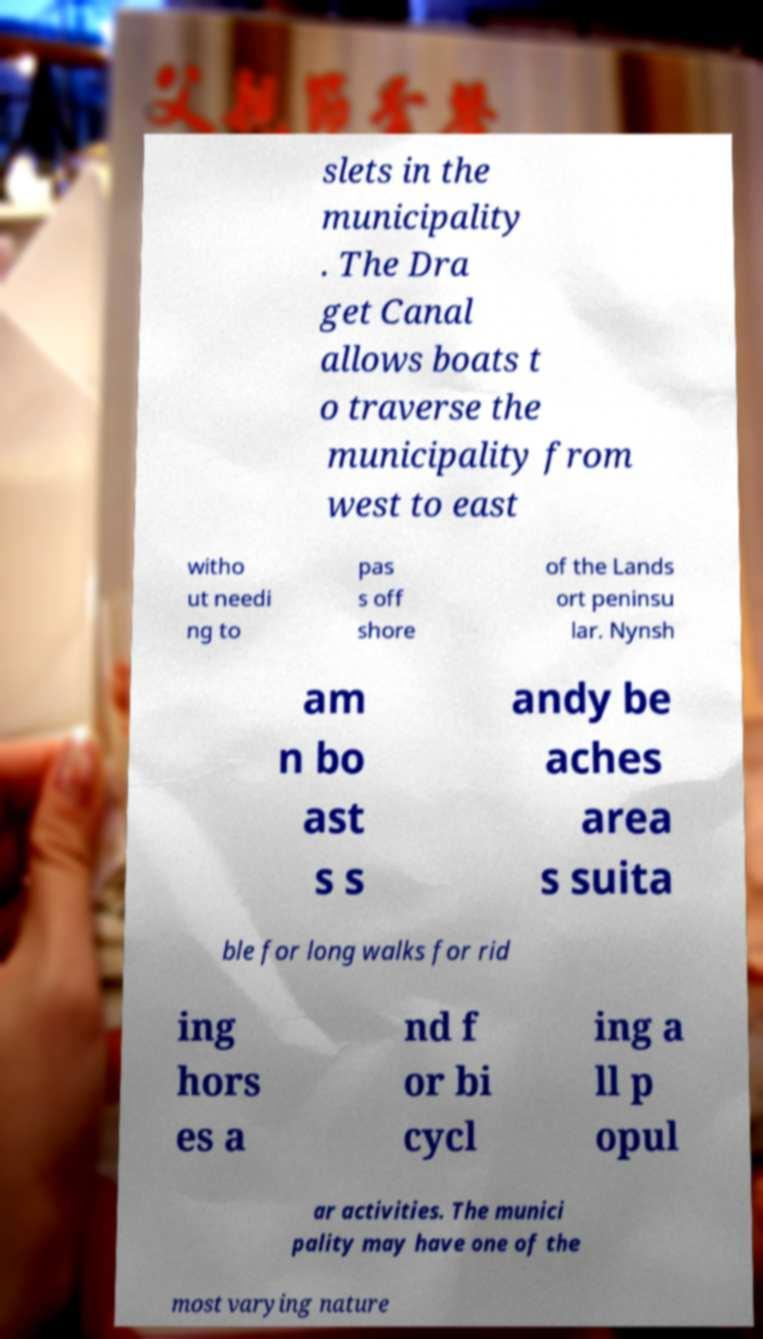What messages or text are displayed in this image? I need them in a readable, typed format. slets in the municipality . The Dra get Canal allows boats t o traverse the municipality from west to east witho ut needi ng to pas s off shore of the Lands ort peninsu lar. Nynsh am n bo ast s s andy be aches area s suita ble for long walks for rid ing hors es a nd f or bi cycl ing a ll p opul ar activities. The munici pality may have one of the most varying nature 